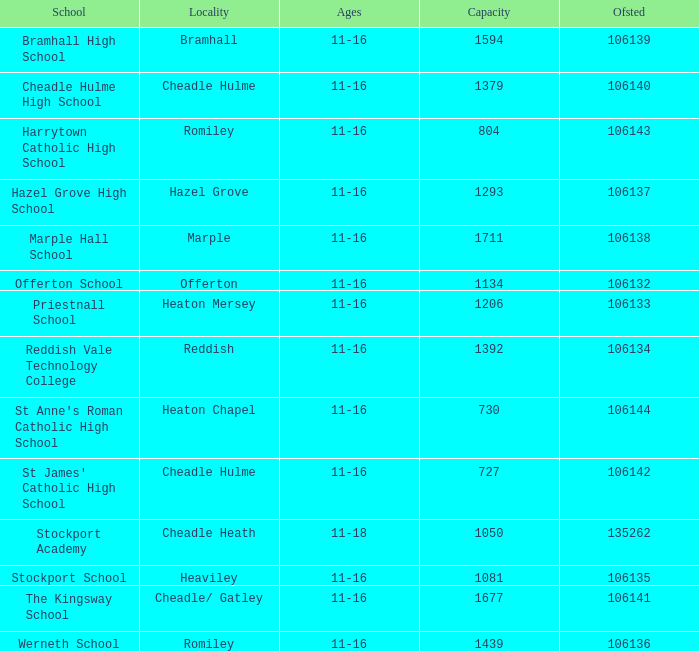Which educational institution can accommodate more than 730 students, has an ofsted rating below 106135, and is situated in heaton mersey? Priestnall School. 